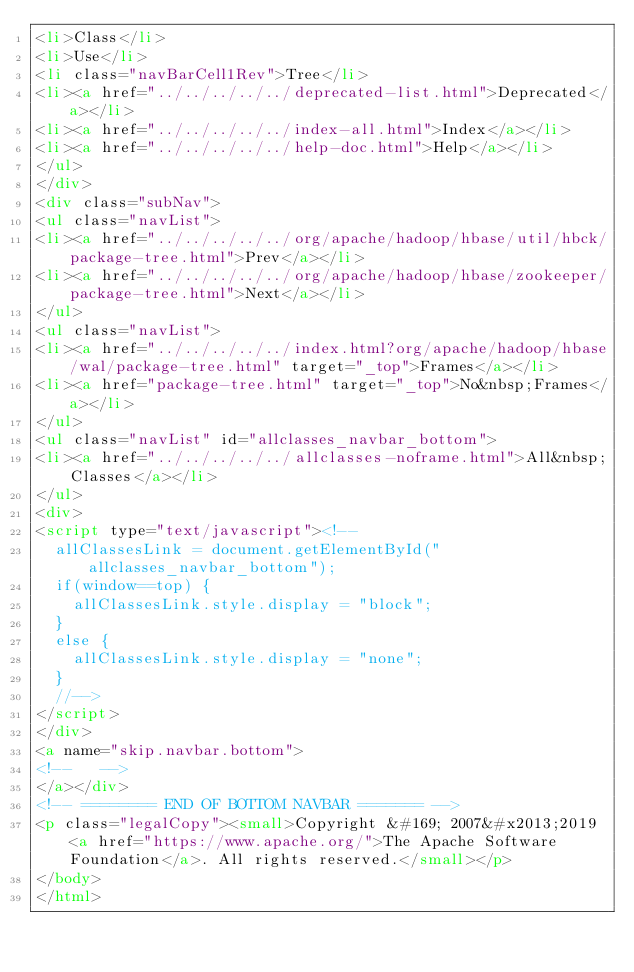Convert code to text. <code><loc_0><loc_0><loc_500><loc_500><_HTML_><li>Class</li>
<li>Use</li>
<li class="navBarCell1Rev">Tree</li>
<li><a href="../../../../../deprecated-list.html">Deprecated</a></li>
<li><a href="../../../../../index-all.html">Index</a></li>
<li><a href="../../../../../help-doc.html">Help</a></li>
</ul>
</div>
<div class="subNav">
<ul class="navList">
<li><a href="../../../../../org/apache/hadoop/hbase/util/hbck/package-tree.html">Prev</a></li>
<li><a href="../../../../../org/apache/hadoop/hbase/zookeeper/package-tree.html">Next</a></li>
</ul>
<ul class="navList">
<li><a href="../../../../../index.html?org/apache/hadoop/hbase/wal/package-tree.html" target="_top">Frames</a></li>
<li><a href="package-tree.html" target="_top">No&nbsp;Frames</a></li>
</ul>
<ul class="navList" id="allclasses_navbar_bottom">
<li><a href="../../../../../allclasses-noframe.html">All&nbsp;Classes</a></li>
</ul>
<div>
<script type="text/javascript"><!--
  allClassesLink = document.getElementById("allclasses_navbar_bottom");
  if(window==top) {
    allClassesLink.style.display = "block";
  }
  else {
    allClassesLink.style.display = "none";
  }
  //-->
</script>
</div>
<a name="skip.navbar.bottom">
<!--   -->
</a></div>
<!-- ======== END OF BOTTOM NAVBAR ======= -->
<p class="legalCopy"><small>Copyright &#169; 2007&#x2013;2019 <a href="https://www.apache.org/">The Apache Software Foundation</a>. All rights reserved.</small></p>
</body>
</html>
</code> 